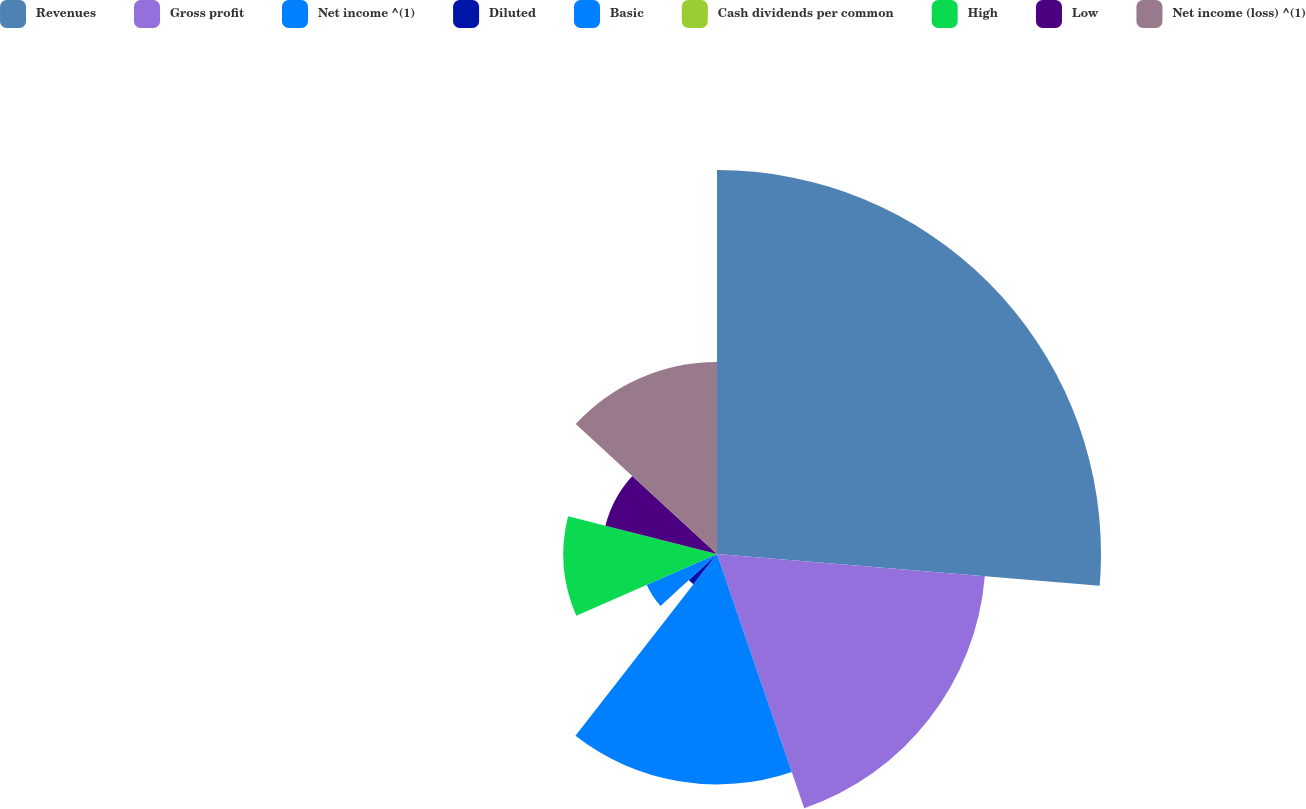<chart> <loc_0><loc_0><loc_500><loc_500><pie_chart><fcel>Revenues<fcel>Gross profit<fcel>Net income ^(1)<fcel>Diluted<fcel>Basic<fcel>Cash dividends per common<fcel>High<fcel>Low<fcel>Net income (loss) ^(1)<nl><fcel>26.32%<fcel>18.42%<fcel>15.79%<fcel>2.63%<fcel>5.26%<fcel>0.0%<fcel>10.53%<fcel>7.89%<fcel>13.16%<nl></chart> 